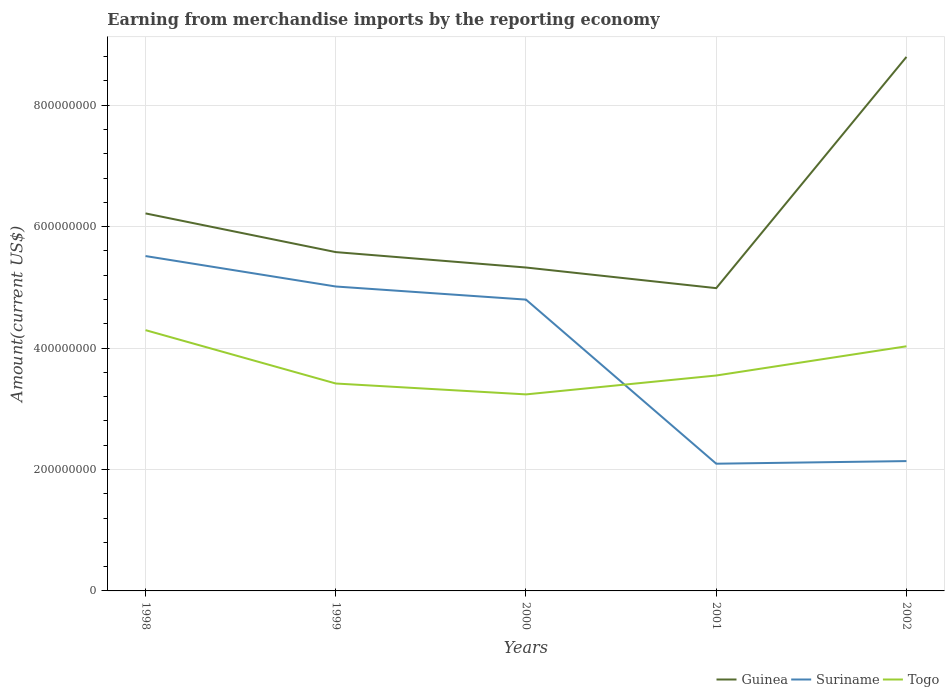Is the number of lines equal to the number of legend labels?
Offer a terse response. Yes. Across all years, what is the maximum amount earned from merchandise imports in Togo?
Keep it short and to the point. 3.24e+08. In which year was the amount earned from merchandise imports in Suriname maximum?
Offer a terse response. 2001. What is the total amount earned from merchandise imports in Togo in the graph?
Keep it short and to the point. 2.66e+07. What is the difference between the highest and the second highest amount earned from merchandise imports in Suriname?
Offer a very short reply. 3.42e+08. What is the difference between the highest and the lowest amount earned from merchandise imports in Guinea?
Your answer should be compact. 2. How many years are there in the graph?
Your response must be concise. 5. What is the difference between two consecutive major ticks on the Y-axis?
Your answer should be very brief. 2.00e+08. Does the graph contain grids?
Your answer should be very brief. Yes. How many legend labels are there?
Provide a short and direct response. 3. How are the legend labels stacked?
Make the answer very short. Horizontal. What is the title of the graph?
Give a very brief answer. Earning from merchandise imports by the reporting economy. What is the label or title of the X-axis?
Offer a terse response. Years. What is the label or title of the Y-axis?
Offer a terse response. Amount(current US$). What is the Amount(current US$) in Guinea in 1998?
Make the answer very short. 6.22e+08. What is the Amount(current US$) of Suriname in 1998?
Your answer should be compact. 5.52e+08. What is the Amount(current US$) of Togo in 1998?
Your response must be concise. 4.30e+08. What is the Amount(current US$) in Guinea in 1999?
Ensure brevity in your answer.  5.58e+08. What is the Amount(current US$) in Suriname in 1999?
Your answer should be compact. 5.01e+08. What is the Amount(current US$) of Togo in 1999?
Your answer should be compact. 3.42e+08. What is the Amount(current US$) of Guinea in 2000?
Your response must be concise. 5.33e+08. What is the Amount(current US$) in Suriname in 2000?
Provide a succinct answer. 4.80e+08. What is the Amount(current US$) in Togo in 2000?
Keep it short and to the point. 3.24e+08. What is the Amount(current US$) in Guinea in 2001?
Your response must be concise. 4.99e+08. What is the Amount(current US$) of Suriname in 2001?
Offer a terse response. 2.10e+08. What is the Amount(current US$) in Togo in 2001?
Your answer should be very brief. 3.55e+08. What is the Amount(current US$) of Guinea in 2002?
Give a very brief answer. 8.80e+08. What is the Amount(current US$) in Suriname in 2002?
Provide a succinct answer. 2.14e+08. What is the Amount(current US$) in Togo in 2002?
Make the answer very short. 4.03e+08. Across all years, what is the maximum Amount(current US$) of Guinea?
Your response must be concise. 8.80e+08. Across all years, what is the maximum Amount(current US$) of Suriname?
Your answer should be compact. 5.52e+08. Across all years, what is the maximum Amount(current US$) in Togo?
Offer a very short reply. 4.30e+08. Across all years, what is the minimum Amount(current US$) in Guinea?
Your answer should be compact. 4.99e+08. Across all years, what is the minimum Amount(current US$) in Suriname?
Keep it short and to the point. 2.10e+08. Across all years, what is the minimum Amount(current US$) in Togo?
Your response must be concise. 3.24e+08. What is the total Amount(current US$) in Guinea in the graph?
Make the answer very short. 3.09e+09. What is the total Amount(current US$) of Suriname in the graph?
Give a very brief answer. 1.96e+09. What is the total Amount(current US$) in Togo in the graph?
Ensure brevity in your answer.  1.85e+09. What is the difference between the Amount(current US$) of Guinea in 1998 and that in 1999?
Offer a terse response. 6.37e+07. What is the difference between the Amount(current US$) of Suriname in 1998 and that in 1999?
Your answer should be compact. 5.02e+07. What is the difference between the Amount(current US$) of Togo in 1998 and that in 1999?
Your answer should be compact. 8.79e+07. What is the difference between the Amount(current US$) in Guinea in 1998 and that in 2000?
Keep it short and to the point. 8.91e+07. What is the difference between the Amount(current US$) of Suriname in 1998 and that in 2000?
Your answer should be compact. 7.18e+07. What is the difference between the Amount(current US$) in Togo in 1998 and that in 2000?
Keep it short and to the point. 1.06e+08. What is the difference between the Amount(current US$) in Guinea in 1998 and that in 2001?
Make the answer very short. 1.23e+08. What is the difference between the Amount(current US$) of Suriname in 1998 and that in 2001?
Keep it short and to the point. 3.42e+08. What is the difference between the Amount(current US$) of Togo in 1998 and that in 2001?
Keep it short and to the point. 7.47e+07. What is the difference between the Amount(current US$) of Guinea in 1998 and that in 2002?
Ensure brevity in your answer.  -2.58e+08. What is the difference between the Amount(current US$) in Suriname in 1998 and that in 2002?
Provide a succinct answer. 3.38e+08. What is the difference between the Amount(current US$) in Togo in 1998 and that in 2002?
Give a very brief answer. 2.66e+07. What is the difference between the Amount(current US$) of Guinea in 1999 and that in 2000?
Make the answer very short. 2.54e+07. What is the difference between the Amount(current US$) of Suriname in 1999 and that in 2000?
Ensure brevity in your answer.  2.16e+07. What is the difference between the Amount(current US$) in Togo in 1999 and that in 2000?
Your response must be concise. 1.79e+07. What is the difference between the Amount(current US$) in Guinea in 1999 and that in 2001?
Your answer should be very brief. 5.94e+07. What is the difference between the Amount(current US$) of Suriname in 1999 and that in 2001?
Provide a short and direct response. 2.92e+08. What is the difference between the Amount(current US$) of Togo in 1999 and that in 2001?
Provide a short and direct response. -1.32e+07. What is the difference between the Amount(current US$) of Guinea in 1999 and that in 2002?
Provide a succinct answer. -3.22e+08. What is the difference between the Amount(current US$) of Suriname in 1999 and that in 2002?
Keep it short and to the point. 2.88e+08. What is the difference between the Amount(current US$) in Togo in 1999 and that in 2002?
Your answer should be compact. -6.13e+07. What is the difference between the Amount(current US$) of Guinea in 2000 and that in 2001?
Your response must be concise. 3.40e+07. What is the difference between the Amount(current US$) in Suriname in 2000 and that in 2001?
Make the answer very short. 2.70e+08. What is the difference between the Amount(current US$) of Togo in 2000 and that in 2001?
Provide a succinct answer. -3.11e+07. What is the difference between the Amount(current US$) in Guinea in 2000 and that in 2002?
Your answer should be compact. -3.47e+08. What is the difference between the Amount(current US$) in Suriname in 2000 and that in 2002?
Offer a very short reply. 2.66e+08. What is the difference between the Amount(current US$) in Togo in 2000 and that in 2002?
Keep it short and to the point. -7.92e+07. What is the difference between the Amount(current US$) in Guinea in 2001 and that in 2002?
Offer a very short reply. -3.81e+08. What is the difference between the Amount(current US$) in Suriname in 2001 and that in 2002?
Your answer should be compact. -4.28e+06. What is the difference between the Amount(current US$) in Togo in 2001 and that in 2002?
Keep it short and to the point. -4.81e+07. What is the difference between the Amount(current US$) of Guinea in 1998 and the Amount(current US$) of Suriname in 1999?
Offer a very short reply. 1.20e+08. What is the difference between the Amount(current US$) in Guinea in 1998 and the Amount(current US$) in Togo in 1999?
Make the answer very short. 2.80e+08. What is the difference between the Amount(current US$) in Suriname in 1998 and the Amount(current US$) in Togo in 1999?
Offer a very short reply. 2.10e+08. What is the difference between the Amount(current US$) in Guinea in 1998 and the Amount(current US$) in Suriname in 2000?
Keep it short and to the point. 1.42e+08. What is the difference between the Amount(current US$) in Guinea in 1998 and the Amount(current US$) in Togo in 2000?
Offer a very short reply. 2.98e+08. What is the difference between the Amount(current US$) of Suriname in 1998 and the Amount(current US$) of Togo in 2000?
Your answer should be compact. 2.28e+08. What is the difference between the Amount(current US$) in Guinea in 1998 and the Amount(current US$) in Suriname in 2001?
Give a very brief answer. 4.12e+08. What is the difference between the Amount(current US$) of Guinea in 1998 and the Amount(current US$) of Togo in 2001?
Offer a terse response. 2.67e+08. What is the difference between the Amount(current US$) in Suriname in 1998 and the Amount(current US$) in Togo in 2001?
Offer a terse response. 1.97e+08. What is the difference between the Amount(current US$) of Guinea in 1998 and the Amount(current US$) of Suriname in 2002?
Ensure brevity in your answer.  4.08e+08. What is the difference between the Amount(current US$) of Guinea in 1998 and the Amount(current US$) of Togo in 2002?
Provide a short and direct response. 2.19e+08. What is the difference between the Amount(current US$) of Suriname in 1998 and the Amount(current US$) of Togo in 2002?
Offer a terse response. 1.49e+08. What is the difference between the Amount(current US$) in Guinea in 1999 and the Amount(current US$) in Suriname in 2000?
Your answer should be compact. 7.83e+07. What is the difference between the Amount(current US$) in Guinea in 1999 and the Amount(current US$) in Togo in 2000?
Your response must be concise. 2.34e+08. What is the difference between the Amount(current US$) in Suriname in 1999 and the Amount(current US$) in Togo in 2000?
Keep it short and to the point. 1.78e+08. What is the difference between the Amount(current US$) of Guinea in 1999 and the Amount(current US$) of Suriname in 2001?
Ensure brevity in your answer.  3.49e+08. What is the difference between the Amount(current US$) of Guinea in 1999 and the Amount(current US$) of Togo in 2001?
Make the answer very short. 2.03e+08. What is the difference between the Amount(current US$) of Suriname in 1999 and the Amount(current US$) of Togo in 2001?
Provide a succinct answer. 1.47e+08. What is the difference between the Amount(current US$) of Guinea in 1999 and the Amount(current US$) of Suriname in 2002?
Your answer should be very brief. 3.44e+08. What is the difference between the Amount(current US$) of Guinea in 1999 and the Amount(current US$) of Togo in 2002?
Give a very brief answer. 1.55e+08. What is the difference between the Amount(current US$) of Suriname in 1999 and the Amount(current US$) of Togo in 2002?
Provide a short and direct response. 9.85e+07. What is the difference between the Amount(current US$) of Guinea in 2000 and the Amount(current US$) of Suriname in 2001?
Make the answer very short. 3.23e+08. What is the difference between the Amount(current US$) of Guinea in 2000 and the Amount(current US$) of Togo in 2001?
Offer a terse response. 1.78e+08. What is the difference between the Amount(current US$) in Suriname in 2000 and the Amount(current US$) in Togo in 2001?
Give a very brief answer. 1.25e+08. What is the difference between the Amount(current US$) in Guinea in 2000 and the Amount(current US$) in Suriname in 2002?
Provide a short and direct response. 3.19e+08. What is the difference between the Amount(current US$) in Guinea in 2000 and the Amount(current US$) in Togo in 2002?
Ensure brevity in your answer.  1.30e+08. What is the difference between the Amount(current US$) of Suriname in 2000 and the Amount(current US$) of Togo in 2002?
Offer a terse response. 7.69e+07. What is the difference between the Amount(current US$) in Guinea in 2001 and the Amount(current US$) in Suriname in 2002?
Your answer should be compact. 2.85e+08. What is the difference between the Amount(current US$) of Guinea in 2001 and the Amount(current US$) of Togo in 2002?
Your response must be concise. 9.58e+07. What is the difference between the Amount(current US$) in Suriname in 2001 and the Amount(current US$) in Togo in 2002?
Provide a short and direct response. -1.93e+08. What is the average Amount(current US$) in Guinea per year?
Keep it short and to the point. 6.18e+08. What is the average Amount(current US$) of Suriname per year?
Provide a short and direct response. 3.91e+08. What is the average Amount(current US$) of Togo per year?
Your answer should be very brief. 3.71e+08. In the year 1998, what is the difference between the Amount(current US$) in Guinea and Amount(current US$) in Suriname?
Make the answer very short. 7.03e+07. In the year 1998, what is the difference between the Amount(current US$) of Guinea and Amount(current US$) of Togo?
Make the answer very short. 1.92e+08. In the year 1998, what is the difference between the Amount(current US$) in Suriname and Amount(current US$) in Togo?
Keep it short and to the point. 1.22e+08. In the year 1999, what is the difference between the Amount(current US$) in Guinea and Amount(current US$) in Suriname?
Provide a short and direct response. 5.67e+07. In the year 1999, what is the difference between the Amount(current US$) of Guinea and Amount(current US$) of Togo?
Give a very brief answer. 2.16e+08. In the year 1999, what is the difference between the Amount(current US$) in Suriname and Amount(current US$) in Togo?
Your answer should be very brief. 1.60e+08. In the year 2000, what is the difference between the Amount(current US$) in Guinea and Amount(current US$) in Suriname?
Your answer should be very brief. 5.29e+07. In the year 2000, what is the difference between the Amount(current US$) in Guinea and Amount(current US$) in Togo?
Provide a short and direct response. 2.09e+08. In the year 2000, what is the difference between the Amount(current US$) of Suriname and Amount(current US$) of Togo?
Provide a succinct answer. 1.56e+08. In the year 2001, what is the difference between the Amount(current US$) of Guinea and Amount(current US$) of Suriname?
Provide a short and direct response. 2.89e+08. In the year 2001, what is the difference between the Amount(current US$) in Guinea and Amount(current US$) in Togo?
Your answer should be compact. 1.44e+08. In the year 2001, what is the difference between the Amount(current US$) of Suriname and Amount(current US$) of Togo?
Your answer should be compact. -1.45e+08. In the year 2002, what is the difference between the Amount(current US$) of Guinea and Amount(current US$) of Suriname?
Provide a succinct answer. 6.66e+08. In the year 2002, what is the difference between the Amount(current US$) of Guinea and Amount(current US$) of Togo?
Your answer should be compact. 4.77e+08. In the year 2002, what is the difference between the Amount(current US$) of Suriname and Amount(current US$) of Togo?
Give a very brief answer. -1.89e+08. What is the ratio of the Amount(current US$) in Guinea in 1998 to that in 1999?
Ensure brevity in your answer.  1.11. What is the ratio of the Amount(current US$) of Suriname in 1998 to that in 1999?
Offer a very short reply. 1.1. What is the ratio of the Amount(current US$) in Togo in 1998 to that in 1999?
Provide a succinct answer. 1.26. What is the ratio of the Amount(current US$) of Guinea in 1998 to that in 2000?
Offer a terse response. 1.17. What is the ratio of the Amount(current US$) of Suriname in 1998 to that in 2000?
Give a very brief answer. 1.15. What is the ratio of the Amount(current US$) in Togo in 1998 to that in 2000?
Make the answer very short. 1.33. What is the ratio of the Amount(current US$) of Guinea in 1998 to that in 2001?
Your answer should be compact. 1.25. What is the ratio of the Amount(current US$) in Suriname in 1998 to that in 2001?
Your answer should be very brief. 2.63. What is the ratio of the Amount(current US$) in Togo in 1998 to that in 2001?
Your response must be concise. 1.21. What is the ratio of the Amount(current US$) in Guinea in 1998 to that in 2002?
Give a very brief answer. 0.71. What is the ratio of the Amount(current US$) in Suriname in 1998 to that in 2002?
Make the answer very short. 2.58. What is the ratio of the Amount(current US$) in Togo in 1998 to that in 2002?
Your answer should be compact. 1.07. What is the ratio of the Amount(current US$) of Guinea in 1999 to that in 2000?
Your answer should be compact. 1.05. What is the ratio of the Amount(current US$) of Suriname in 1999 to that in 2000?
Your response must be concise. 1.04. What is the ratio of the Amount(current US$) in Togo in 1999 to that in 2000?
Offer a terse response. 1.06. What is the ratio of the Amount(current US$) of Guinea in 1999 to that in 2001?
Provide a short and direct response. 1.12. What is the ratio of the Amount(current US$) in Suriname in 1999 to that in 2001?
Give a very brief answer. 2.39. What is the ratio of the Amount(current US$) of Togo in 1999 to that in 2001?
Your answer should be very brief. 0.96. What is the ratio of the Amount(current US$) in Guinea in 1999 to that in 2002?
Your response must be concise. 0.63. What is the ratio of the Amount(current US$) of Suriname in 1999 to that in 2002?
Your answer should be compact. 2.34. What is the ratio of the Amount(current US$) in Togo in 1999 to that in 2002?
Provide a short and direct response. 0.85. What is the ratio of the Amount(current US$) of Guinea in 2000 to that in 2001?
Your answer should be very brief. 1.07. What is the ratio of the Amount(current US$) in Suriname in 2000 to that in 2001?
Offer a terse response. 2.29. What is the ratio of the Amount(current US$) in Togo in 2000 to that in 2001?
Provide a short and direct response. 0.91. What is the ratio of the Amount(current US$) in Guinea in 2000 to that in 2002?
Offer a very short reply. 0.61. What is the ratio of the Amount(current US$) of Suriname in 2000 to that in 2002?
Ensure brevity in your answer.  2.24. What is the ratio of the Amount(current US$) in Togo in 2000 to that in 2002?
Give a very brief answer. 0.8. What is the ratio of the Amount(current US$) of Guinea in 2001 to that in 2002?
Offer a terse response. 0.57. What is the ratio of the Amount(current US$) of Suriname in 2001 to that in 2002?
Keep it short and to the point. 0.98. What is the ratio of the Amount(current US$) in Togo in 2001 to that in 2002?
Your answer should be very brief. 0.88. What is the difference between the highest and the second highest Amount(current US$) of Guinea?
Provide a short and direct response. 2.58e+08. What is the difference between the highest and the second highest Amount(current US$) of Suriname?
Keep it short and to the point. 5.02e+07. What is the difference between the highest and the second highest Amount(current US$) of Togo?
Your response must be concise. 2.66e+07. What is the difference between the highest and the lowest Amount(current US$) of Guinea?
Offer a very short reply. 3.81e+08. What is the difference between the highest and the lowest Amount(current US$) of Suriname?
Offer a terse response. 3.42e+08. What is the difference between the highest and the lowest Amount(current US$) in Togo?
Provide a succinct answer. 1.06e+08. 